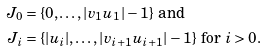<formula> <loc_0><loc_0><loc_500><loc_500>J _ { 0 } & = \{ 0 , \dots , | v _ { 1 } u _ { 1 } | - 1 \} \text { and} \\ J _ { i } & = \{ | u _ { i } | , \dots , | v _ { i + 1 } u _ { i + 1 } | - 1 \} \text { for $i>0$.}</formula> 